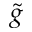<formula> <loc_0><loc_0><loc_500><loc_500>\tilde { g }</formula> 